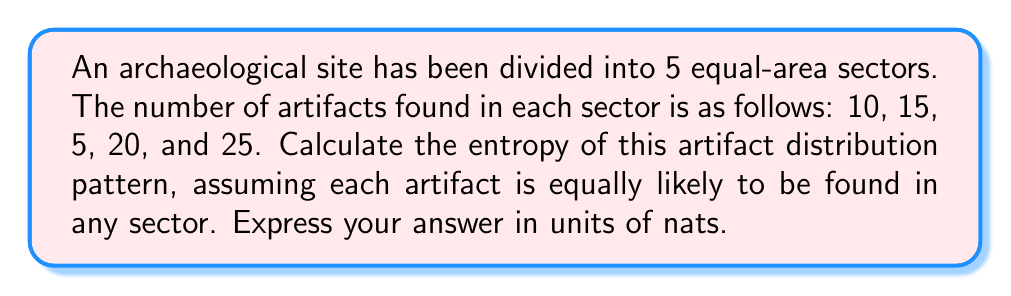Help me with this question. To calculate the entropy of the artifact distribution pattern, we'll follow these steps:

1) First, we need to calculate the total number of artifacts:
   $N_{total} = 10 + 15 + 5 + 20 + 25 = 75$

2) Next, we calculate the probability of finding an artifact in each sector:
   $p_1 = 10/75 = 2/15$
   $p_2 = 15/75 = 1/5$
   $p_3 = 5/75 = 1/15$
   $p_4 = 20/75 = 4/15$
   $p_5 = 25/75 = 1/3$

3) The entropy formula in nats is:
   $$S = -\sum_{i=1}^{n} p_i \ln(p_i)$$

4) Let's calculate each term:
   $-p_1 \ln(p_1) = -(2/15) \ln(2/15) \approx 0.2645$
   $-p_2 \ln(p_2) = -(1/5) \ln(1/5) \approx 0.3220$
   $-p_3 \ln(p_3) = -(1/15) \ln(1/15) \approx 0.1699$
   $-p_4 \ln(p_4) = -(4/15) \ln(4/15) \approx 0.3675$
   $-p_5 \ln(p_5) = -(1/3) \ln(1/3) \approx 0.3662$

5) Sum all these terms:
   $S = 0.2645 + 0.3220 + 0.1699 + 0.3675 + 0.3662 = 1.4901$ nats

Therefore, the entropy of the artifact distribution pattern is approximately 1.4901 nats.
Answer: 1.4901 nats 